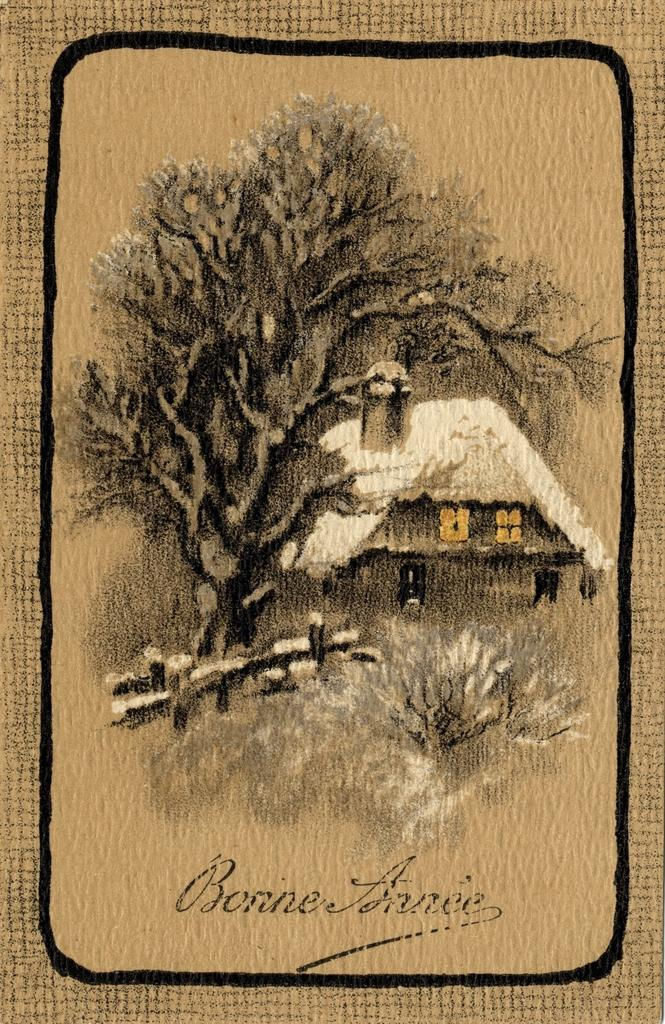What type of artwork is depicted in the image? There is a painting of a house and a painting of a tree in the image. What other elements can be seen in the image besides the paintings? There is text present in the image. How many ducks are swimming in the water in the image? There are no ducks or water present in the image; it features paintings of a house and a tree, along with text. 